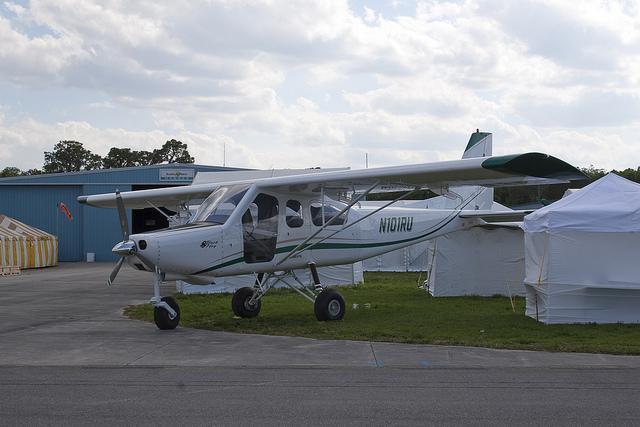How many men are there?
Give a very brief answer. 0. 